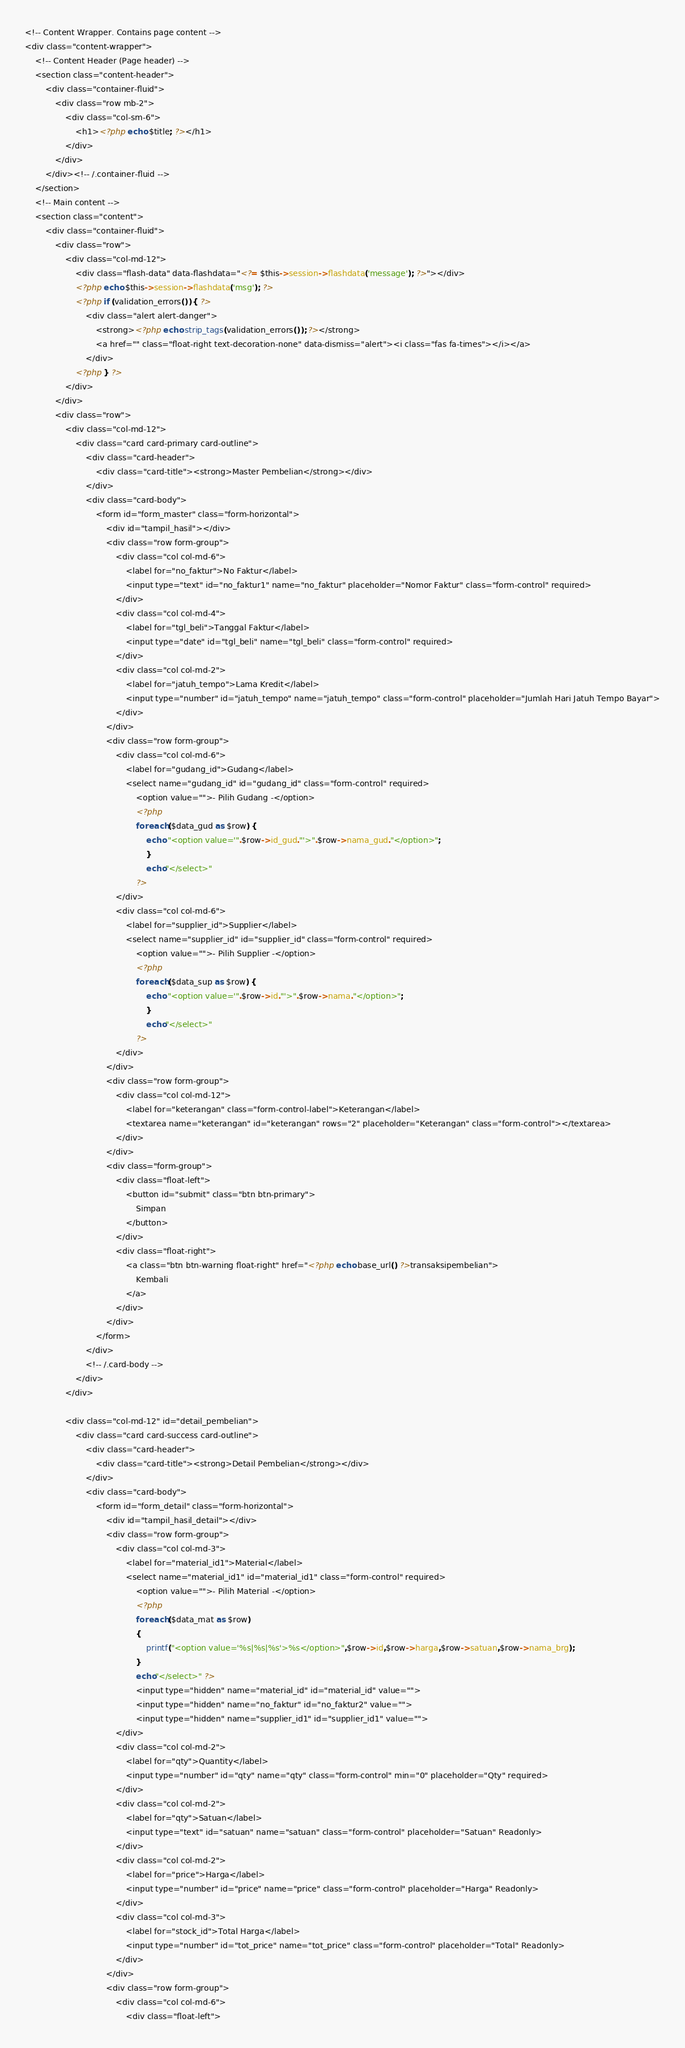Convert code to text. <code><loc_0><loc_0><loc_500><loc_500><_PHP_><!-- Content Wrapper. Contains page content -->
<div class="content-wrapper">
    <!-- Content Header (Page header) -->
    <section class="content-header">
        <div class="container-fluid">
            <div class="row mb-2">
                <div class="col-sm-6">
                    <h1><?php echo $title; ?></h1>
                </div>
            </div>
        </div><!-- /.container-fluid -->
    </section>
    <!-- Main content -->
    <section class="content">
        <div class="container-fluid">
            <div class="row">
                <div class="col-md-12">
                    <div class="flash-data" data-flashdata="<?= $this->session->flashdata('message'); ?>"></div>
                    <?php echo $this->session->flashdata('msg'); ?>
                    <?php if (validation_errors()) { ?>
                        <div class="alert alert-danger">
                            <strong><?php echo strip_tags(validation_errors()); ?></strong>
                            <a href="" class="float-right text-decoration-none" data-dismiss="alert"><i class="fas fa-times"></i></a>
                        </div>
                    <?php } ?>
                </div>
            </div>
            <div class="row">
                <div class="col-md-12">
                    <div class="card card-primary card-outline">
                        <div class="card-header">
                            <div class="card-title"><strong>Master Pembelian</strong></div>
                        </div>
                        <div class="card-body">
                            <form id="form_master" class="form-horizontal">
                                <div id="tampil_hasil"></div>
                                <div class="row form-group">
                                    <div class="col col-md-6">
                                        <label for="no_faktur">No Faktur</label>
                                        <input type="text" id="no_faktur1" name="no_faktur" placeholder="Nomor Faktur" class="form-control" required>
                                    </div>
                                    <div class="col col-md-4">
                                        <label for="tgl_beli">Tanggal Faktur</label>
                                        <input type="date" id="tgl_beli" name="tgl_beli" class="form-control" required>
                                    </div>
                                    <div class="col col-md-2">
                                        <label for="jatuh_tempo">Lama Kredit</label>
                                        <input type="number" id="jatuh_tempo" name="jatuh_tempo" class="form-control" placeholder="Jumlah Hari Jatuh Tempo Bayar">
                                    </div>
                                </div>
                                <div class="row form-group">
                                    <div class="col col-md-6">
                                        <label for="gudang_id">Gudang</label>
                                        <select name="gudang_id" id="gudang_id" class="form-control" required>
                                            <option value="">- Pilih Gudang -</option>
                                            <?php                                
                                            foreach ($data_gud as $row) {  
                                                echo "<option value='".$row->id_gud."'>".$row->nama_gud."</option>";
                                                }
                                                echo"</select>"
                                            ?>
                                    </div>
                                    <div class="col col-md-6">
                                        <label for="supplier_id">Supplier</label>
                                        <select name="supplier_id" id="supplier_id" class="form-control" required>
                                            <option value="">- Pilih Supplier -</option>
                                            <?php                                
                                            foreach ($data_sup as $row) {  
                                                echo "<option value='".$row->id."'>".$row->nama."</option>";
                                                }
                                                echo"</select>"
                                            ?>
                                    </div>
                                </div>
                                <div class="row form-group">
                                    <div class="col col-md-12">
                                        <label for="keterangan" class="form-control-label">Keterangan</label>
                                        <textarea name="keterangan" id="keterangan" rows="2" placeholder="Keterangan" class="form-control"></textarea>
                                    </div>
                                </div>
                                <div class="form-group">
                                    <div class="float-left">
                                        <button id="submit" class="btn btn-primary">
                                            Simpan
                                        </button>
                                    </div>
                                    <div class="float-right">
                                        <a class="btn btn-warning float-right" href="<?php echo base_url() ?>transaksipembelian">
                                            Kembali
                                        </a>
                                    </div>
                                </div>
                            </form>
                        </div>
                        <!-- /.card-body -->
                    </div>
                </div>

                <div class="col-md-12" id="detail_pembelian">
                    <div class="card card-success card-outline">
                        <div class="card-header">
                            <div class="card-title"><strong>Detail Pembelian</strong></div>
                        </div>
                        <div class="card-body">
                            <form id="form_detail" class="form-horizontal">
                                <div id="tampil_hasil_detail"></div>
                                <div class="row form-group">
                                    <div class="col col-md-3">
                                        <label for="material_id1">Material</label>
                                        <select name="material_id1" id="material_id1" class="form-control" required>
                                            <option value="">- Pilih Material -</option>
                                            <?php                                
                                            foreach ($data_mat as $row)
                                            {  
                                                printf("<option value='%s|%s|%s'>%s</option>",$row->id,$row->harga,$row->satuan,$row->nama_brg);
                                            }
                                            echo"</select>" ?>
                                            <input type="hidden" name="material_id" id="material_id" value="">
                                            <input type="hidden" name="no_faktur" id="no_faktur2" value="">
                                            <input type="hidden" name="supplier_id1" id="supplier_id1" value="">
                                    </div>
                                    <div class="col col-md-2">
                                        <label for="qty">Quantity</label>
                                        <input type="number" id="qty" name="qty" class="form-control" min="0" placeholder="Qty" required>
                                    </div>
                                    <div class="col col-md-2">
                                        <label for="qty">Satuan</label>
                                        <input type="text" id="satuan" name="satuan" class="form-control" placeholder="Satuan" Readonly>
                                    </div>
                                    <div class="col col-md-2">
                                        <label for="price">Harga</label>
                                        <input type="number" id="price" name="price" class="form-control" placeholder="Harga" Readonly>
                                    </div>
                                    <div class="col col-md-3">
                                        <label for="stock_id">Total Harga</label>
                                        <input type="number" id="tot_price" name="tot_price" class="form-control" placeholder="Total" Readonly>
                                    </div>
                                </div>
                                <div class="row form-group">
                                    <div class="col col-md-6"> 
                                        <div class="float-left"></code> 